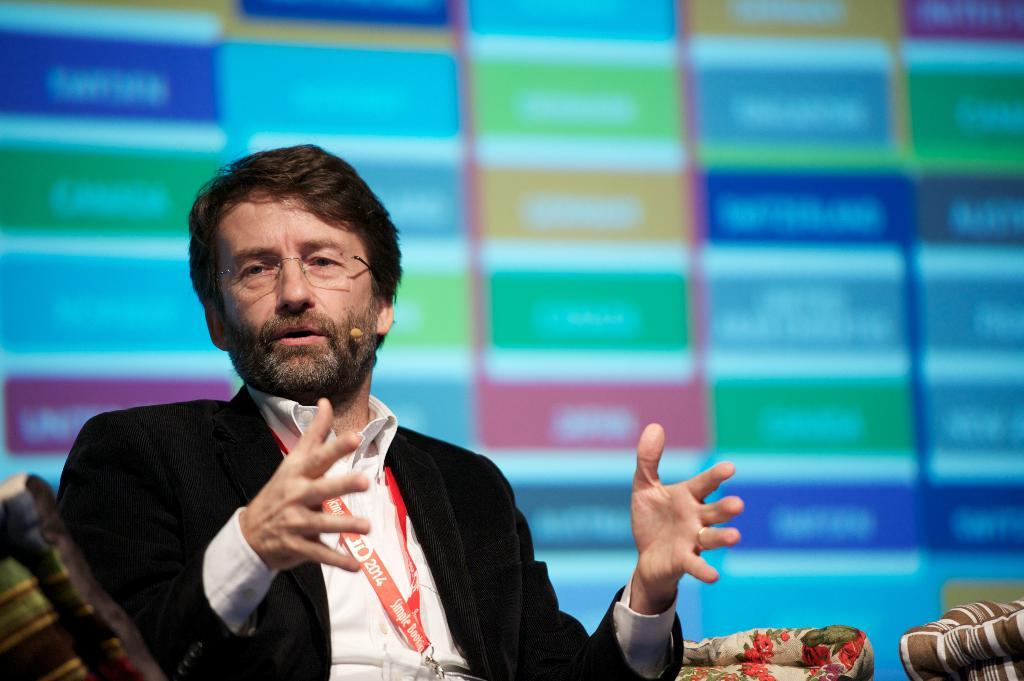What is the main subject of the image? There is a man in the image. What is the man doing in the image? The man is sitting in a chair. What is the man wearing in the image? The man is wearing a black coat. Can you describe any additional details about the man? The man has a red tag around his neck. How would you describe the background of the image? The background of the image is blurred. What type of plant is the man using to stop the car in the image? There is no plant or car present in the image; it features a man sitting in a chair with a black coat and a red tag around his neck. 